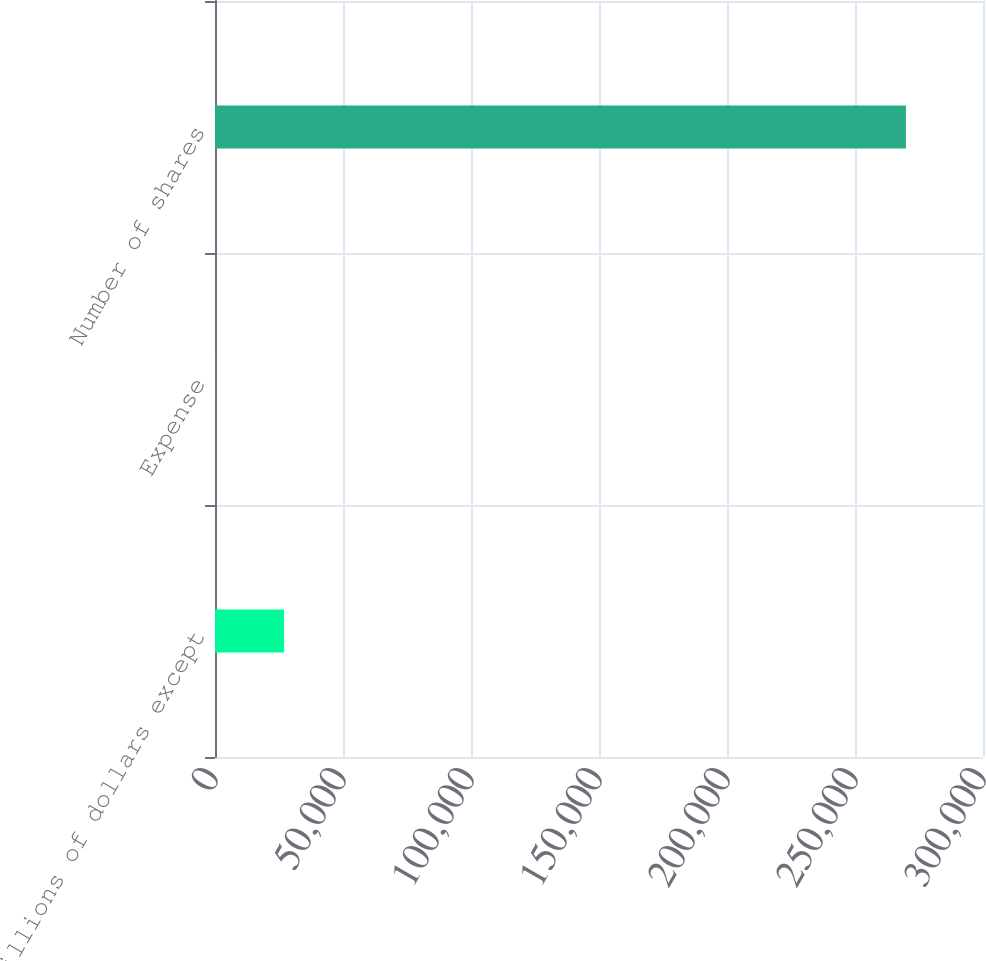<chart> <loc_0><loc_0><loc_500><loc_500><bar_chart><fcel>(millions of dollars except<fcel>Expense<fcel>Number of shares<nl><fcel>26999.2<fcel>10.7<fcel>269896<nl></chart> 